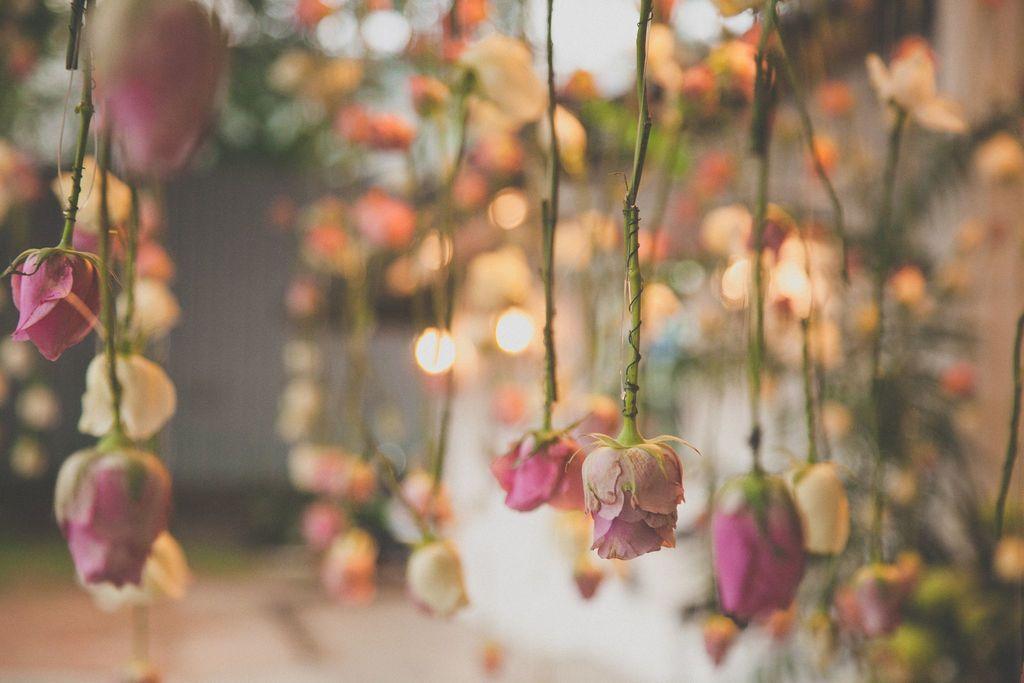Describe this image in one or two sentences. In this image we can see roses are hanging, there are lights, the background is blurry. 